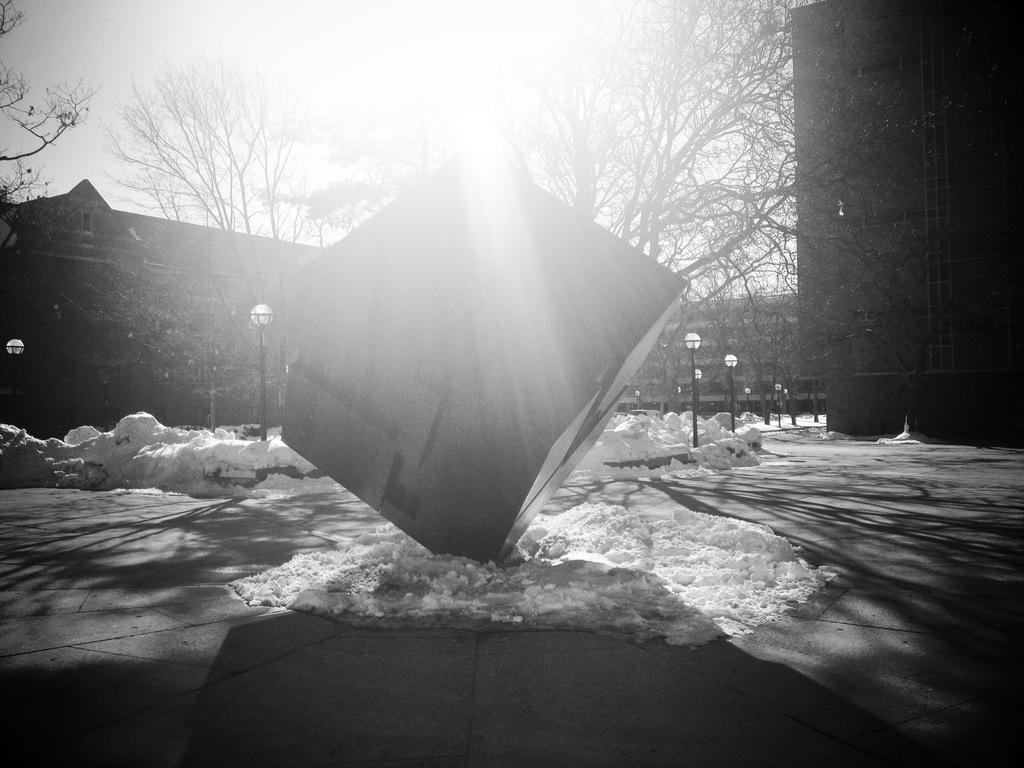What type of weather condition is depicted in the image? There is snow in the image, indicating a winter scene. What type of lighting is present in the image? There are street lamps in the image, providing illumination. What type of structures can be seen in the image? There are buildings in the image, suggesting an urban or suburban setting. What type of vegetation is present in the image? There are trees in the image, adding to the natural elements of the scene. What is visible in the sky in the image? The sky is visible in the image, allowing us to see the weather conditions and time of day. How many pizzas are being delivered in the image? There are no pizzas or delivery services present in the image. Is there any poison visible in the image? There is no poison present in the image. 